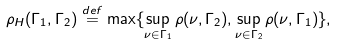Convert formula to latex. <formula><loc_0><loc_0><loc_500><loc_500>\rho _ { H } ( \Gamma _ { 1 } , \Gamma _ { 2 } ) \stackrel { d e f } { = } \max \{ \sup _ { \nu \in \Gamma _ { 1 } } \rho ( \nu , \Gamma _ { 2 } ) , \sup _ { \nu \in \Gamma _ { 2 } } \rho ( \nu , \Gamma _ { 1 } ) \} , \</formula> 